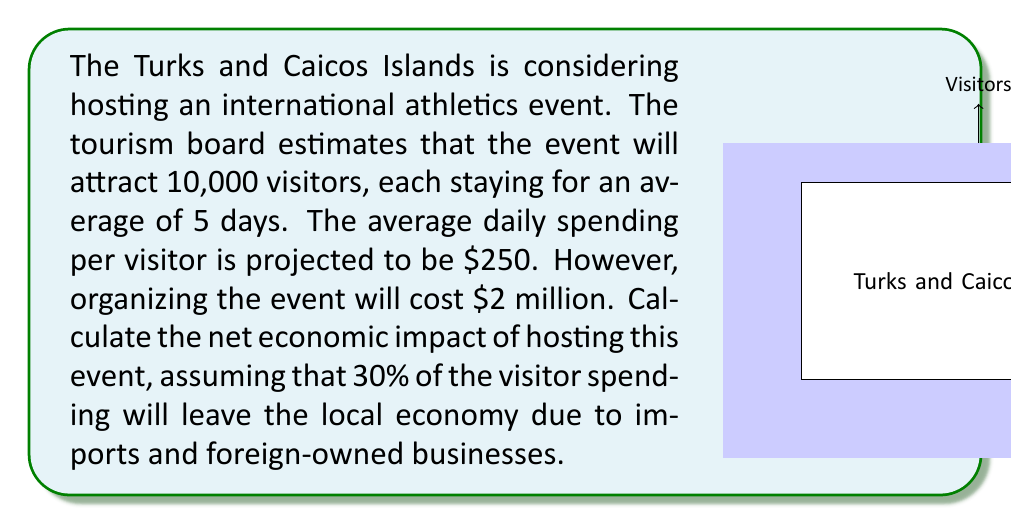Show me your answer to this math problem. Let's break this problem down step-by-step:

1) Calculate total visitor spending:
   Number of visitors: 10,000
   Average stay: 5 days
   Daily spending: $250
   Total spending = $10,000 \times 5 \times $250 = $12,500,000

2) Calculate the amount retained in the local economy:
   70% of the spending remains in the local economy
   Local economic benefit = $12,500,000 \times 0.70 = $8,750,000

3) Calculate the net economic impact:
   Net impact = Local economic benefit - Event cost
               = $8,750,000 - $2,000,000 = $6,750,000

We can express this calculation using the following formula:

$$ \text{Net Impact} = (V \times D \times S \times (1-L)) - C $$

Where:
$V$ = Number of visitors
$D$ = Average duration of stay
$S$ = Average daily spending
$L$ = Leakage rate (proportion leaving the local economy)
$C$ = Cost of organizing the event

Plugging in our values:

$$ \text{Net Impact} = (10,000 \times 5 \times $250 \times (1-0.30)) - $2,000,000 = $6,750,000 $$

Therefore, the net economic impact of hosting the international athletics event on the Turks and Caicos Islands' economy is $6,750,000.
Answer: $6,750,000 